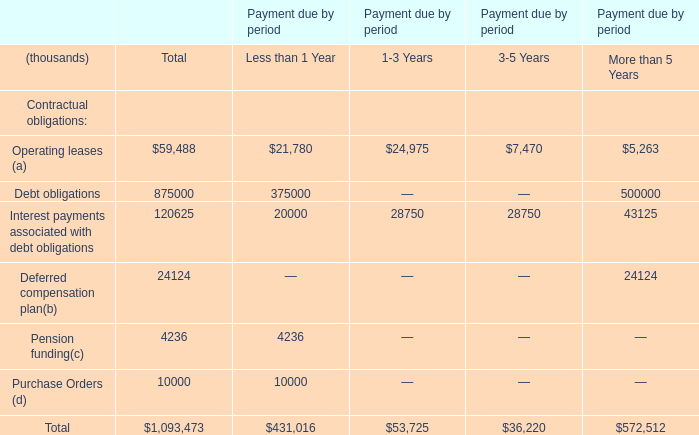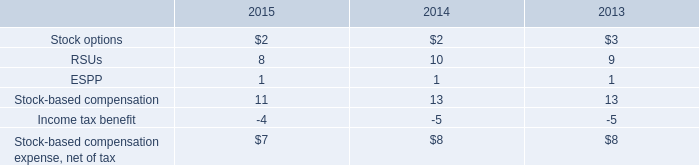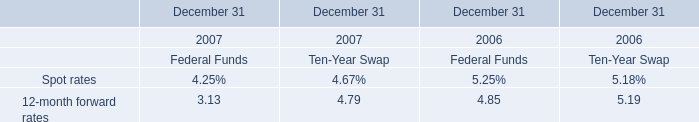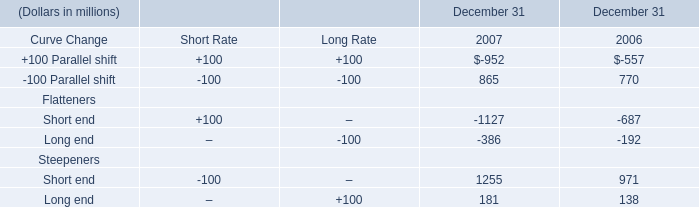as of december 31 . 2015 what was the % ( % ) of shares available for grant under the 2007 plan . 
Computations: (8.4 / 15.5)
Answer: 0.54194. 